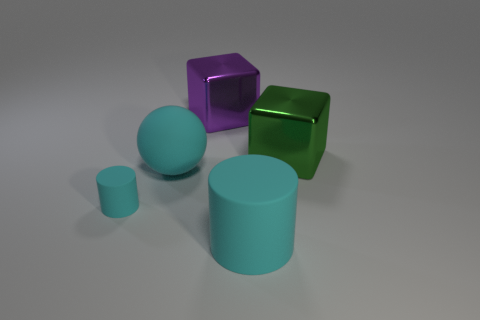What shape is the big object that is the same color as the big ball?
Give a very brief answer. Cylinder. Are there any other things that have the same color as the large matte cylinder?
Keep it short and to the point. Yes. There is a large cylinder; is it the same color as the rubber thing behind the small rubber cylinder?
Offer a very short reply. Yes. What number of small purple matte balls are there?
Keep it short and to the point. 0. What number of objects are green cubes or small red objects?
Your answer should be compact. 1. The sphere that is the same color as the big cylinder is what size?
Your response must be concise. Large. Are there any big cyan matte objects left of the large cyan matte sphere?
Keep it short and to the point. No. Are there more big cyan cylinders to the left of the small object than metal things behind the green shiny thing?
Provide a succinct answer. No. What size is the other cyan matte thing that is the same shape as the tiny cyan object?
Give a very brief answer. Large. How many cylinders are either big shiny objects or green objects?
Give a very brief answer. 0. 